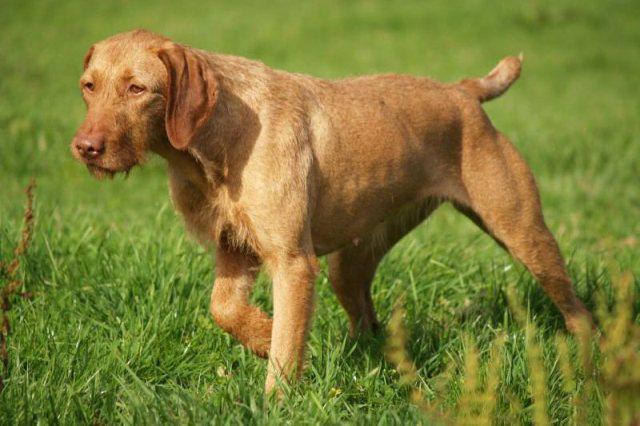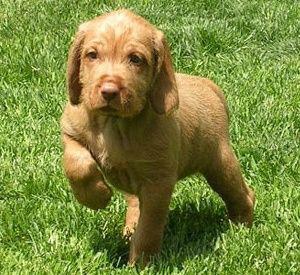The first image is the image on the left, the second image is the image on the right. Given the left and right images, does the statement "The right image shows one forward-looking puppy standing on grass with the front paw on the left raised." hold true? Answer yes or no. Yes. The first image is the image on the left, the second image is the image on the right. Evaluate the accuracy of this statement regarding the images: "There are at least three puppies.". Is it true? Answer yes or no. No. 